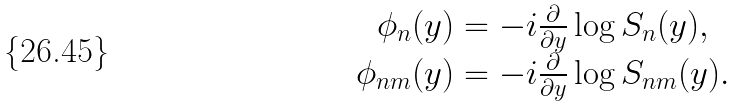Convert formula to latex. <formula><loc_0><loc_0><loc_500><loc_500>\begin{array} { c } { { \phi _ { n } ( y ) = - i \frac { \partial } { \partial y } \log S _ { n } ( y ) , } } \\ { { \phi _ { n m } ( y ) = - i \frac { \partial } { \partial y } \log S _ { n m } ( y ) . } } \end{array}</formula> 